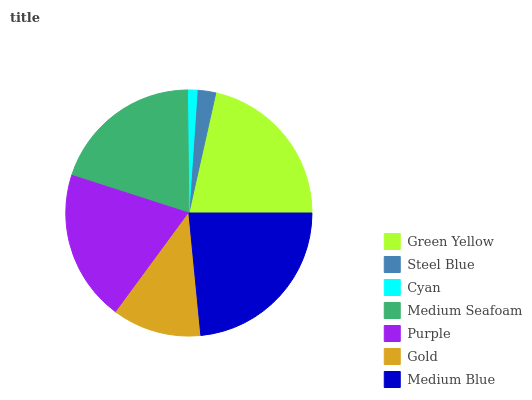Is Cyan the minimum?
Answer yes or no. Yes. Is Medium Blue the maximum?
Answer yes or no. Yes. Is Steel Blue the minimum?
Answer yes or no. No. Is Steel Blue the maximum?
Answer yes or no. No. Is Green Yellow greater than Steel Blue?
Answer yes or no. Yes. Is Steel Blue less than Green Yellow?
Answer yes or no. Yes. Is Steel Blue greater than Green Yellow?
Answer yes or no. No. Is Green Yellow less than Steel Blue?
Answer yes or no. No. Is Medium Seafoam the high median?
Answer yes or no. Yes. Is Medium Seafoam the low median?
Answer yes or no. Yes. Is Steel Blue the high median?
Answer yes or no. No. Is Steel Blue the low median?
Answer yes or no. No. 